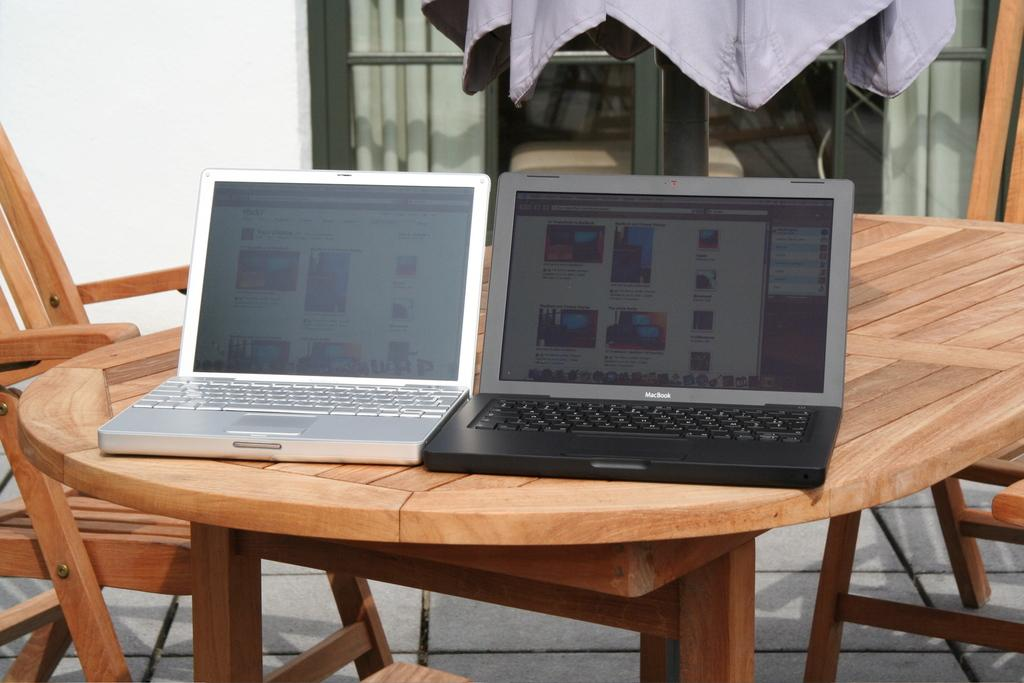What type of furniture is present in the image? There is a table and a chair in the image. What objects are placed on the table? There are two laptops on the table, one silver and one black, as well as a jacket. What is the color of the silver laptop? The silver laptop is silver in color. What is the color of the black laptop? The black laptop is black in color. How many toes can be seen on the goat in the image? There is no goat present in the image, so it is not possible to determine the number of toes. 